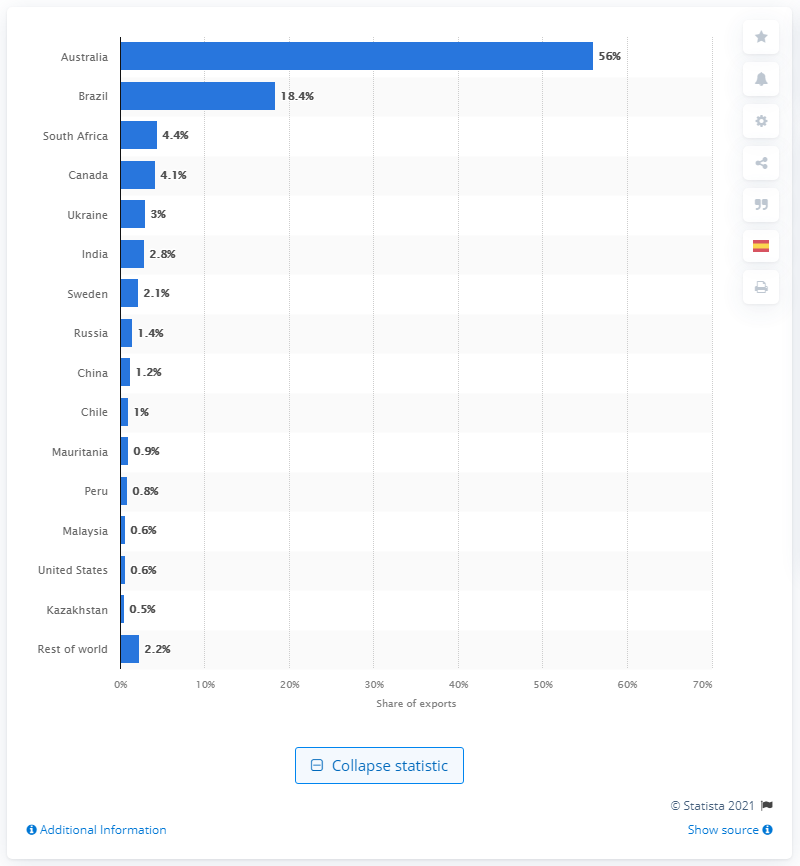Specify some key components in this picture. In 2020, approximately 56% of global iron ore exports were sourced from Australia. 